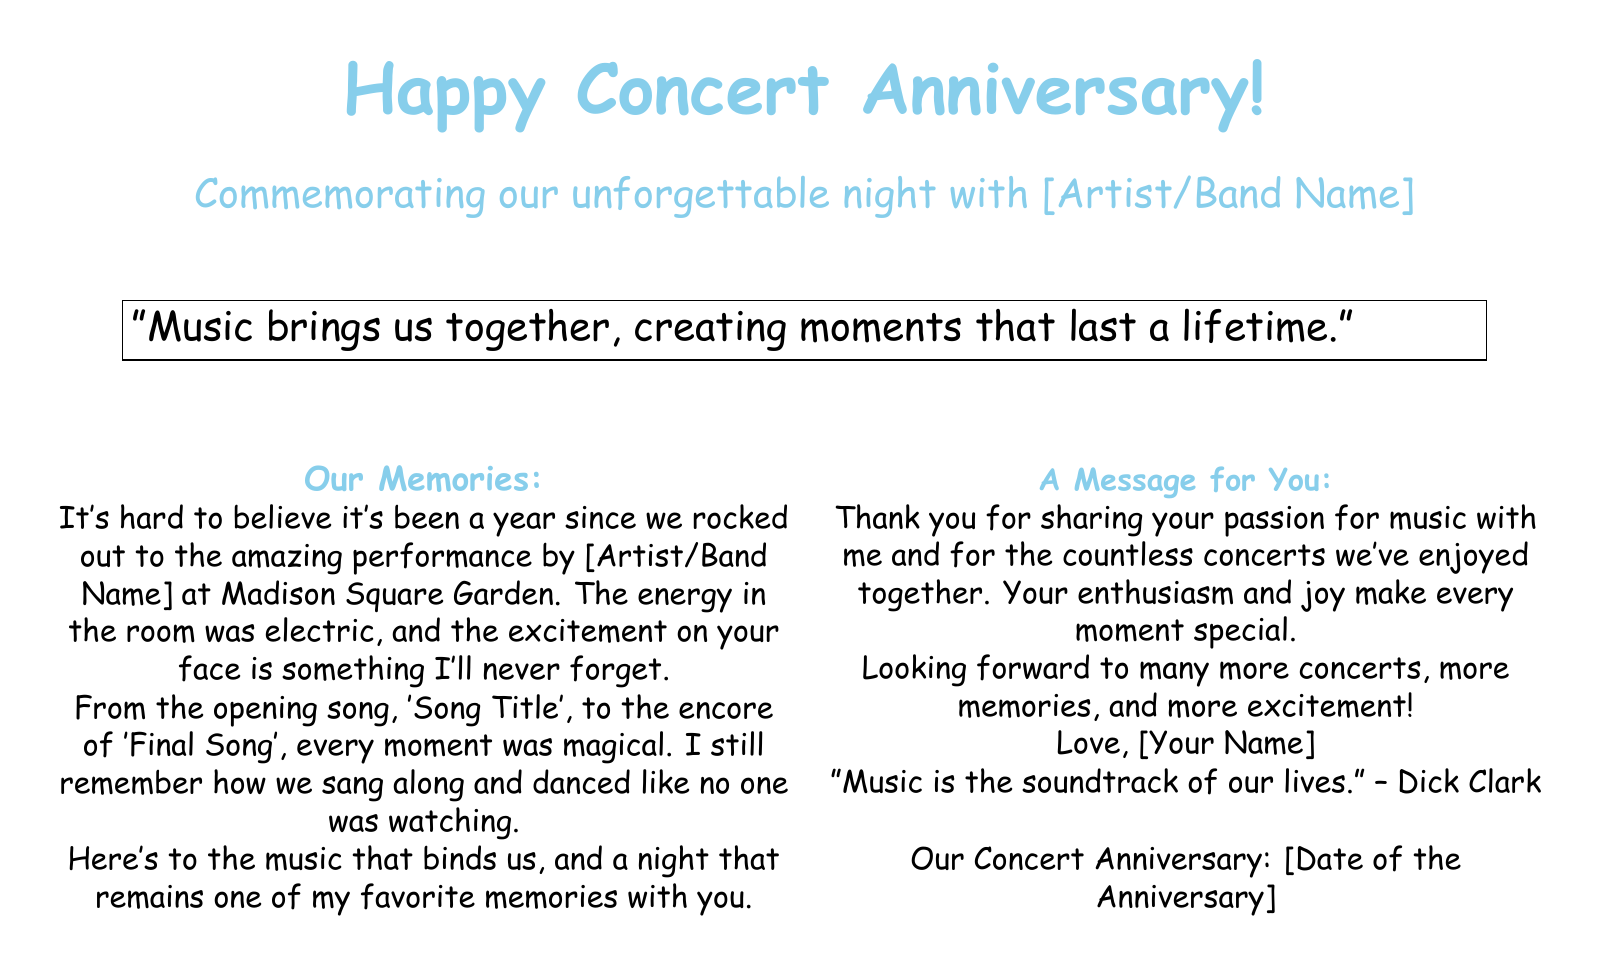What is the occasion celebrated in the card? The card commemorates a notable event related to a concert, which is specified as an anniversary.
Answer: Concert Anniversary Who performed at the concert? The artist or band name is included in the text where the memories are detailed.
Answer: [Artist/Band Name] What was the venue for the concert? The venue where the concert took place is mentioned in the document.
Answer: Madison Square Garden What is one of the songs mentioned in the memories? The examples of songs are included in the narrative, emphasizing the concert experience.
Answer: 'Song Title' What is the date of the concert anniversary? The document indicates a specific date to celebrate the anniversary.
Answer: [Date of the Anniversary] What sentiment is expressed about music in the quote? The quote within the card reflects how music connects people and creates lasting memories.
Answer: "Music brings us together, creating moments that last a lifetime." What type of font is used in the document? The style of the font chosen for the card is specified for the text presentation.
Answer: Comic Sans MS What color scheme is primarily used in the card design? The document incorporates specific colors throughout its graphical elements, which are mentioned.
Answer: Pink and Blue What was the emotion conveyed during the concert? The description includes how the event made the card sender feel during the concert night.
Answer: Electric 